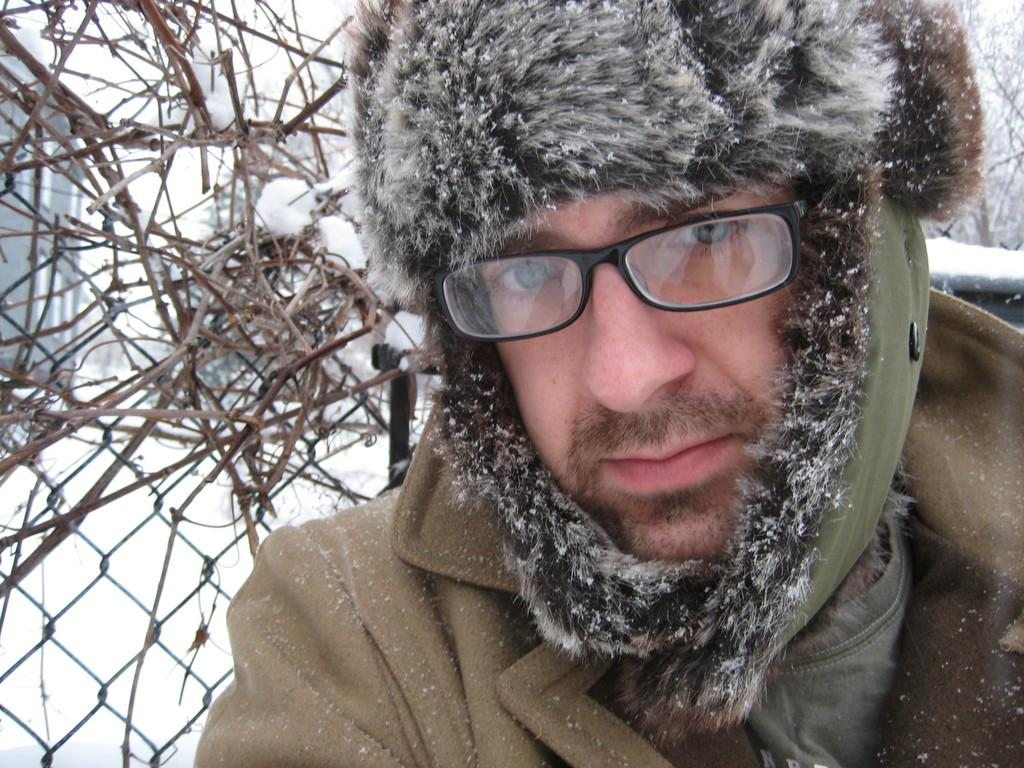Who is in the image? There is a man in the image. What is the man wearing? The man is wearing a jacket. What can be seen behind the man? There is a fence behind the man. What is on the fence? Dry branches are present on the fence. What is the weather like in the image? There is a heavy snowfall in the image. How many potatoes can be seen on the man's wrist in the image? There are no potatoes or any reference to a wrist in the image. 